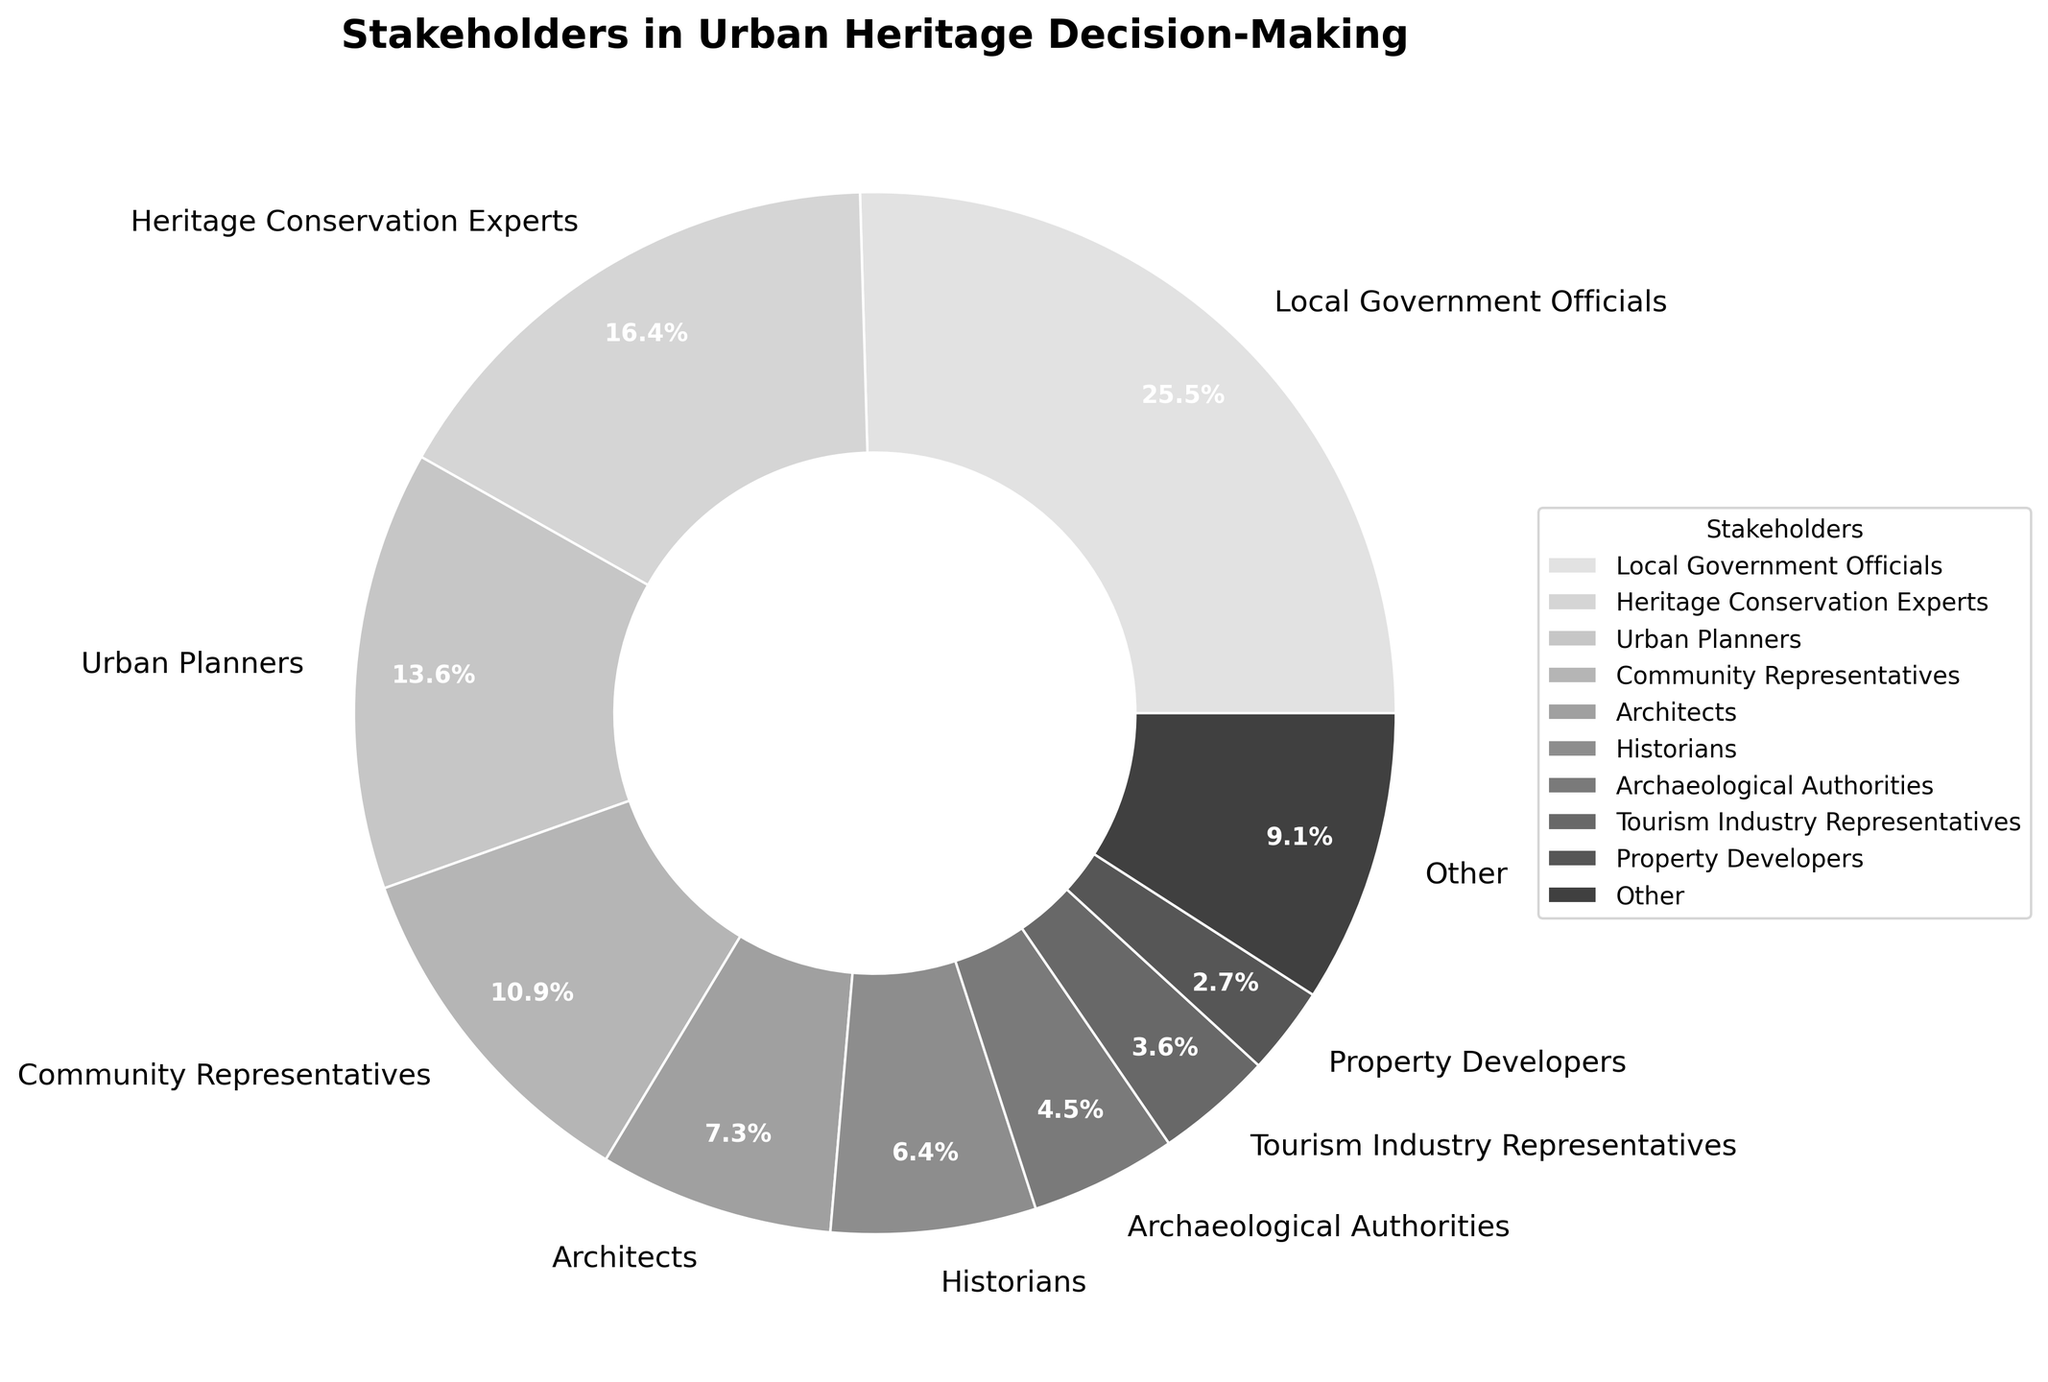what is the combined percentage of Heritage Conservation Experts and Urban Planners? The pie chart shows the percentage of different stakeholders involved. Heritage Conservation Experts are 18% and Urban Planners are 15%. Adding these gives 18 + 15 = 33%.
Answer: 33% Which group contributes the smallest share to the decision-making process? The pie chart includes various stakeholders with their percentage contributions. Legal Consultants and Funding Agency Representatives each have 1%, which is the smallest percentage.
Answer: Legal Consultants and Funding Agency Representatives Is the percentage of Local Government Officials greater than twice the combined percentage of Environmental Scientists and Cultural NGOs? Local Government Officials contribute 28%. Let's find the combined percentage of Environmental Scientists and Cultural NGOs, which are each 2%, so 2 + 2 = 4%. Twice this combined value is 2 * 4% = 8%. Since 28% is greater than 8%, the percentage of Local Government Officials is indeed greater.
Answer: Yes What is the percentage difference between Community Representatives and Architects? Community Representatives contribute 12% while Architects contribute 8%. Subtracting these values gives 12% - 8% = 4%.
Answer: 4% Which stakeholder group has the second highest percentage? The pie chart provides percentage contributions, with Local Government Officials contributing the highest at 28%, followed by Heritage Conservation Experts at 18%. Thus, the group with the second highest percentage is Heritage Conservation Experts.
Answer: Heritage Conservation Experts Is the combined percentage of Historians, Archaeological Authorities, and Tourism Industry Representatives larger than that of Community Representatives? We sum up Historians (7%), Archaeological Authorities (5%), and Tourism Industry Representatives (4%) to get 7 + 5 + 4 = 16%, which is larger than the Community Representatives' 12%.
Answer: Yes Are the combined percentages of Local Government Officials and Property Developers equal to 31%? Local Government Officials contribute 28% and Property Developers contribute 3%. Adding these percentages gives 28 + 3 = 31%.
Answer: Yes 